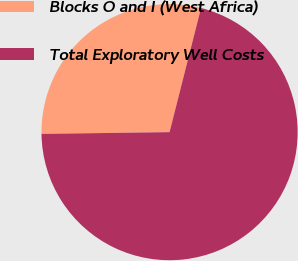<chart> <loc_0><loc_0><loc_500><loc_500><pie_chart><fcel>Blocks O and I (West Africa)<fcel>Total Exploratory Well Costs<nl><fcel>29.17%<fcel>70.83%<nl></chart> 